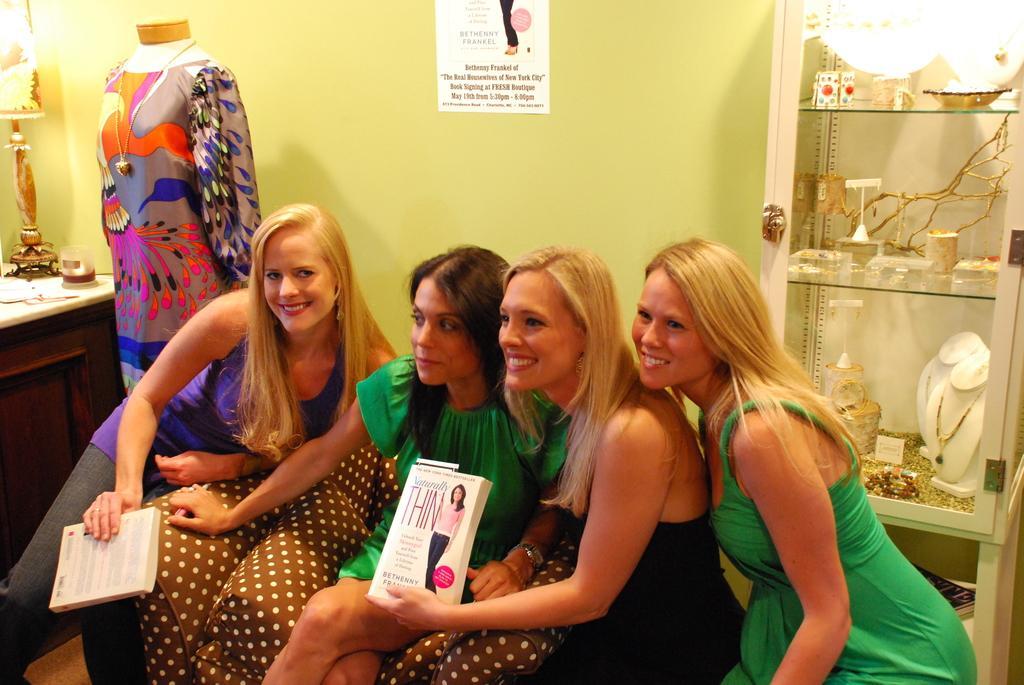Can you describe this image briefly? In a room there are 4 women sitting. 2 of them are holding books in their hands. Behind them there is a shelf in which there there are accessories and other items. There is a mannequin at the left and a green wall at the back. 